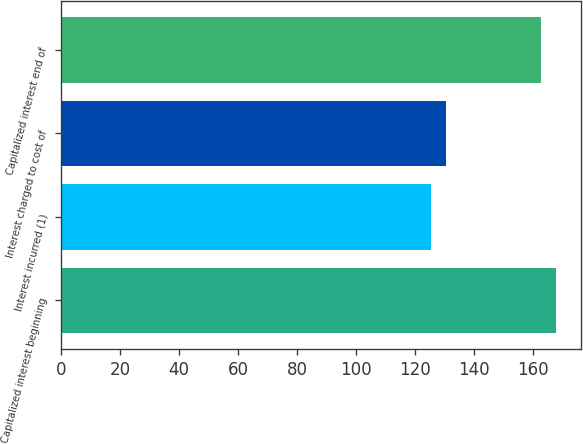<chart> <loc_0><loc_0><loc_500><loc_500><bar_chart><fcel>Capitalized interest beginning<fcel>Interest incurred (1)<fcel>Interest charged to cost of<fcel>Capitalized interest end of<nl><fcel>167.9<fcel>125.4<fcel>130.6<fcel>162.7<nl></chart> 